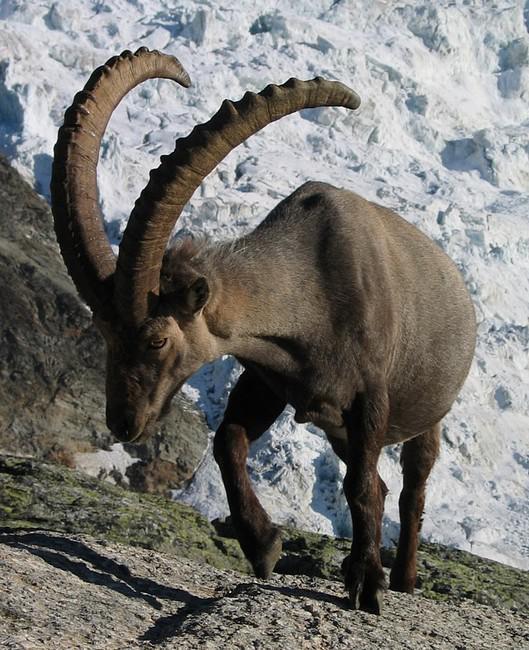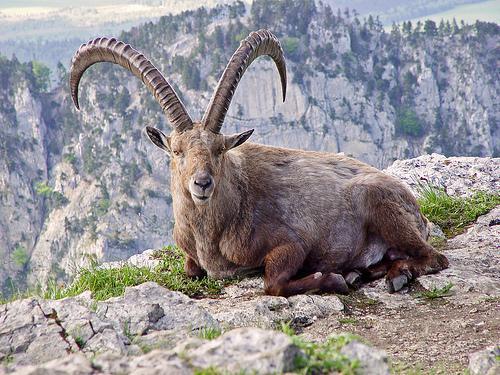The first image is the image on the left, the second image is the image on the right. For the images shown, is this caption "An image shows one camera-facing long-horned animal with an upright head, with mountain peaks in the background." true? Answer yes or no. Yes. The first image is the image on the left, the second image is the image on the right. Examine the images to the left and right. Is the description "A horned animal is posed with a view of the mountains behind it." accurate? Answer yes or no. Yes. The first image is the image on the left, the second image is the image on the right. Given the left and right images, does the statement "the animals in the image on the right are on a steep hillside." hold true? Answer yes or no. No. The first image is the image on the left, the second image is the image on the right. Examine the images to the left and right. Is the description "Left image shows exactly one horned animal, with both horns showing clearly and separately." accurate? Answer yes or no. Yes. 